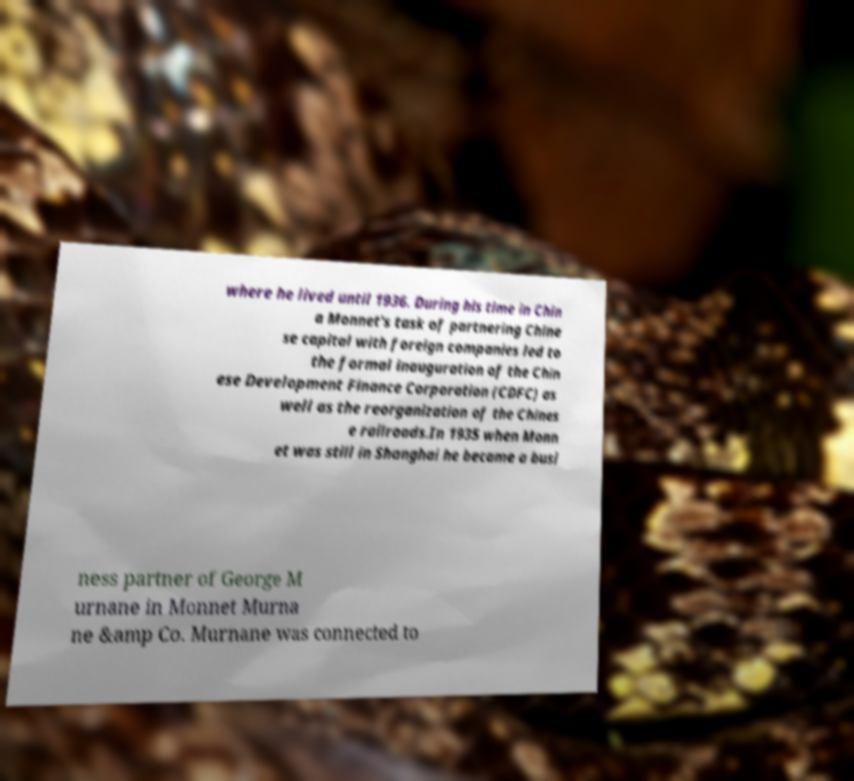I need the written content from this picture converted into text. Can you do that? where he lived until 1936. During his time in Chin a Monnet's task of partnering Chine se capital with foreign companies led to the formal inauguration of the Chin ese Development Finance Corporation (CDFC) as well as the reorganization of the Chines e railroads.In 1935 when Monn et was still in Shanghai he became a busi ness partner of George M urnane in Monnet Murna ne &amp Co. Murnane was connected to 